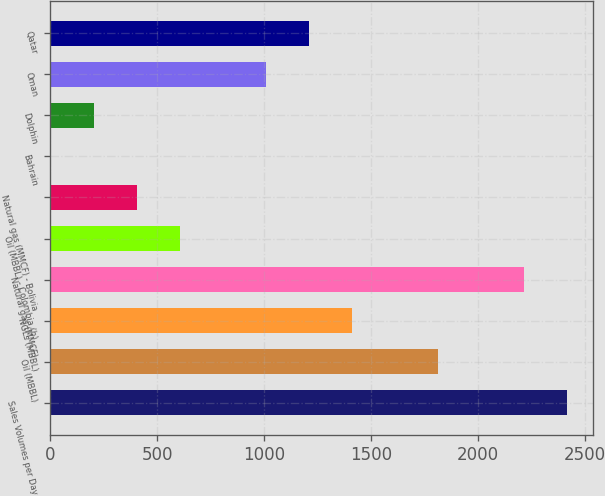<chart> <loc_0><loc_0><loc_500><loc_500><bar_chart><fcel>Sales Volumes per Day<fcel>Oil (MBBL)<fcel>NGLs (MBBL)<fcel>Natural gas (MMCF)<fcel>Oil (MBBL) - Colombia (b)<fcel>Natural gas (MMCF) - Bolivia<fcel>Bahrain<fcel>Dolphin<fcel>Oman<fcel>Qatar<nl><fcel>2413.6<fcel>1811.2<fcel>1409.6<fcel>2212.8<fcel>606.4<fcel>405.6<fcel>4<fcel>204.8<fcel>1008<fcel>1208.8<nl></chart> 